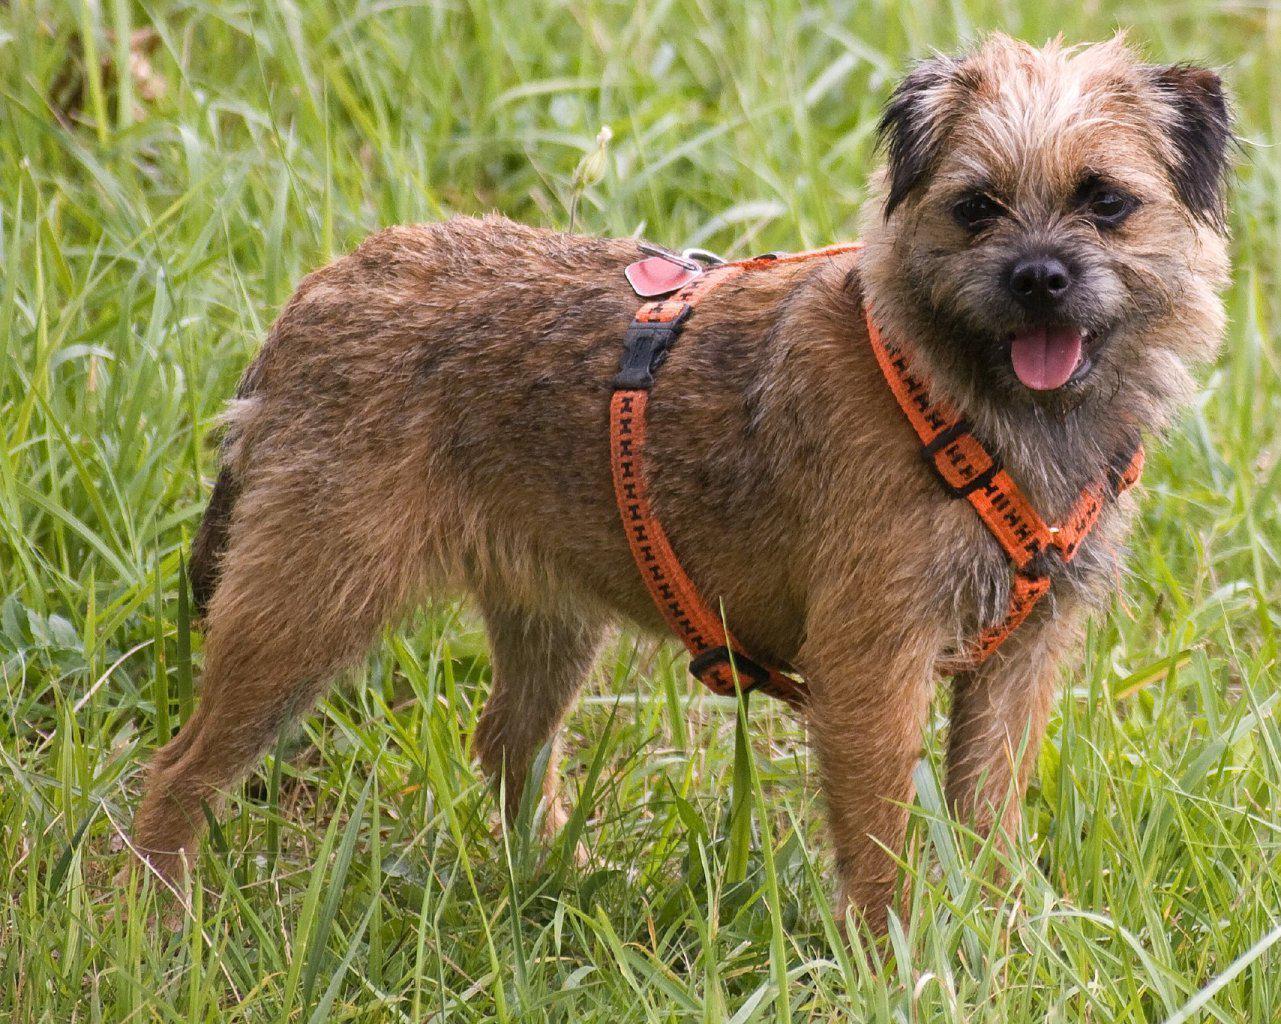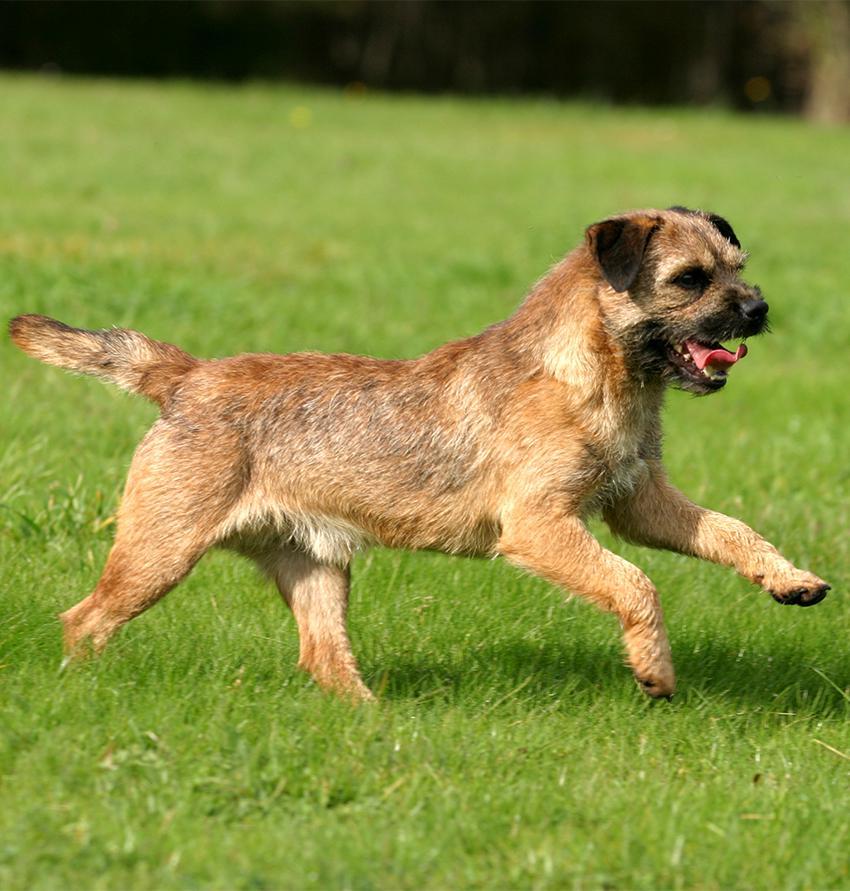The first image is the image on the left, the second image is the image on the right. For the images shown, is this caption "The right image contains exactly one dog standing on grass facing towards the right." true? Answer yes or no. Yes. 